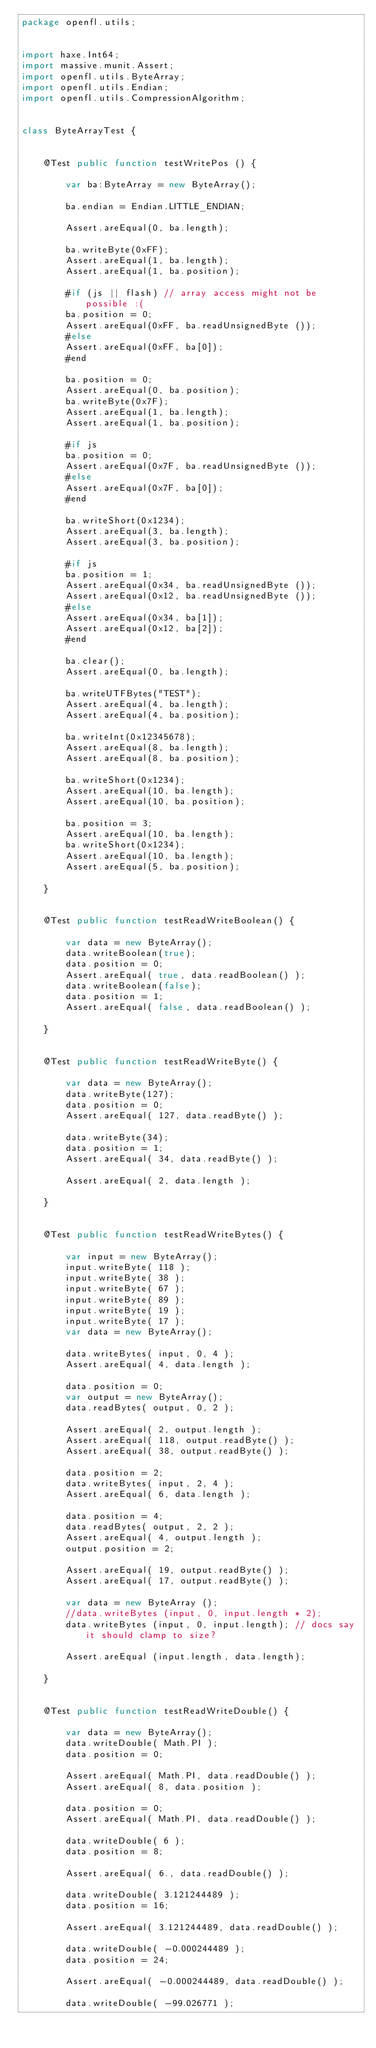Convert code to text. <code><loc_0><loc_0><loc_500><loc_500><_Haxe_>package openfl.utils;


import haxe.Int64;
import massive.munit.Assert;
import openfl.utils.ByteArray;
import openfl.utils.Endian;
import openfl.utils.CompressionAlgorithm;


class ByteArrayTest {

	
	@Test public function testWritePos () {
		
		var ba:ByteArray = new ByteArray();
		
		ba.endian = Endian.LITTLE_ENDIAN;
		
		Assert.areEqual(0, ba.length);
		
		ba.writeByte(0xFF);
		Assert.areEqual(1, ba.length);
		Assert.areEqual(1, ba.position);
		
		#if (js || flash) // array access might not be possible :(
		ba.position = 0;
		Assert.areEqual(0xFF, ba.readUnsignedByte ());
		#else
		Assert.areEqual(0xFF, ba[0]);
		#end
		
		ba.position = 0;
		Assert.areEqual(0, ba.position);
		ba.writeByte(0x7F);
		Assert.areEqual(1, ba.length);
		Assert.areEqual(1, ba.position);
		
		#if js
		ba.position = 0;
		Assert.areEqual(0x7F, ba.readUnsignedByte ());
		#else
		Assert.areEqual(0x7F, ba[0]);
		#end
		
		ba.writeShort(0x1234);
		Assert.areEqual(3, ba.length);
		Assert.areEqual(3, ba.position);
		
		#if js
		ba.position = 1;
		Assert.areEqual(0x34, ba.readUnsignedByte ());
		Assert.areEqual(0x12, ba.readUnsignedByte ());
		#else
		Assert.areEqual(0x34, ba[1]);
		Assert.areEqual(0x12, ba[2]);
		#end
		
		ba.clear();
		Assert.areEqual(0, ba.length);
		
		ba.writeUTFBytes("TEST");
		Assert.areEqual(4, ba.length);
		Assert.areEqual(4, ba.position);
		
		ba.writeInt(0x12345678);
		Assert.areEqual(8, ba.length);
		Assert.areEqual(8, ba.position);
		
		ba.writeShort(0x1234);
		Assert.areEqual(10, ba.length);
		Assert.areEqual(10, ba.position);
		
		ba.position = 3;
		Assert.areEqual(10, ba.length);
		ba.writeShort(0x1234);
		Assert.areEqual(10, ba.length);
		Assert.areEqual(5, ba.position);
		
	}
	
	
	@Test public function testReadWriteBoolean() {
		
		var data = new ByteArray();
		data.writeBoolean(true);
		data.position = 0;
		Assert.areEqual( true, data.readBoolean() );
		data.writeBoolean(false);
		data.position = 1;
		Assert.areEqual( false, data.readBoolean() );
		
	}
	
	
	@Test public function testReadWriteByte() {
		
		var data = new ByteArray();
		data.writeByte(127);
		data.position = 0;
		Assert.areEqual( 127, data.readByte() );
		
		data.writeByte(34);
		data.position = 1;
		Assert.areEqual( 34, data.readByte() );
		
		Assert.areEqual( 2, data.length );
		
	}
	
	
	@Test public function testReadWriteBytes() {
		
		var input = new ByteArray();
		input.writeByte( 118 );
		input.writeByte( 38 );
		input.writeByte( 67 );
		input.writeByte( 89 );
		input.writeByte( 19 );
		input.writeByte( 17 );
		var data = new ByteArray();
		
		data.writeBytes( input, 0, 4 );
		Assert.areEqual( 4, data.length );
		
		data.position = 0;
		var output = new ByteArray();
		data.readBytes( output, 0, 2 );
		
		Assert.areEqual( 2, output.length );
		Assert.areEqual( 118, output.readByte() );
		Assert.areEqual( 38, output.readByte() );
		
		data.position = 2;
		data.writeBytes( input, 2, 4 );
		Assert.areEqual( 6, data.length );
		
		data.position = 4;
		data.readBytes( output, 2, 2 );
		Assert.areEqual( 4, output.length );
		output.position = 2;
		
		Assert.areEqual( 19, output.readByte() );
		Assert.areEqual( 17, output.readByte() );
		
		var data = new ByteArray ();
		//data.writeBytes (input, 0, input.length * 2);
		data.writeBytes (input, 0, input.length); // docs say it should clamp to size?
		
		Assert.areEqual (input.length, data.length);
		
	}
	
	
	@Test public function testReadWriteDouble() {
		
		var data = new ByteArray();
		data.writeDouble( Math.PI );
		data.position = 0;
		
		Assert.areEqual( Math.PI, data.readDouble() );
		Assert.areEqual( 8, data.position );
		
		data.position = 0;
		Assert.areEqual( Math.PI, data.readDouble() );
		
		data.writeDouble( 6 );
		data.position = 8;
		
		Assert.areEqual( 6., data.readDouble() );
		
		data.writeDouble( 3.121244489 );
		data.position = 16;
		
		Assert.areEqual( 3.121244489, data.readDouble() );
		
		data.writeDouble( -0.000244489 );
		data.position = 24;
		
		Assert.areEqual( -0.000244489, data.readDouble() );
		
		data.writeDouble( -99.026771 );</code> 